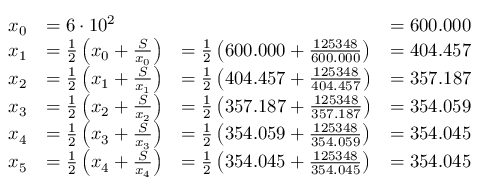Convert formula to latex. <formula><loc_0><loc_0><loc_500><loc_500>{ \begin{array} { r } { { \begin{array} { r l l l } { x _ { 0 } } & { = 6 \cdot 1 0 ^ { 2 } } & & { = 6 0 0 . 0 0 0 } \\ { x _ { 1 } } & { = { \frac { 1 } { 2 } } \left ( x _ { 0 } + { \frac { S } { x _ { 0 } } } \right ) } & { = { \frac { 1 } { 2 } } \left ( 6 0 0 . 0 0 0 + { \frac { 1 2 5 3 4 8 } { 6 0 0 . 0 0 0 } } \right ) } & { = 4 0 4 . 4 5 7 } \\ { x _ { 2 } } & { = { \frac { 1 } { 2 } } \left ( x _ { 1 } + { \frac { S } { x _ { 1 } } } \right ) } & { = { \frac { 1 } { 2 } } \left ( 4 0 4 . 4 5 7 + { \frac { 1 2 5 3 4 8 } { 4 0 4 . 4 5 7 } } \right ) } & { = 3 5 7 . 1 8 7 } \\ { x _ { 3 } } & { = { \frac { 1 } { 2 } } \left ( x _ { 2 } + { \frac { S } { x _ { 2 } } } \right ) } & { = { \frac { 1 } { 2 } } \left ( 3 5 7 . 1 8 7 + { \frac { 1 2 5 3 4 8 } { 3 5 7 . 1 8 7 } } \right ) } & { = 3 5 4 . 0 5 9 } \\ { x _ { 4 } } & { = { \frac { 1 } { 2 } } \left ( x _ { 3 } + { \frac { S } { x _ { 3 } } } \right ) } & { = { \frac { 1 } { 2 } } \left ( 3 5 4 . 0 5 9 + { \frac { 1 2 5 3 4 8 } { 3 5 4 . 0 5 9 } } \right ) } & { = 3 5 4 . 0 4 5 } \\ { x _ { 5 } } & { = { \frac { 1 } { 2 } } \left ( x _ { 4 } + { \frac { S } { x _ { 4 } } } \right ) } & { = { \frac { 1 } { 2 } } \left ( 3 5 4 . 0 4 5 + { \frac { 1 2 5 3 4 8 } { 3 5 4 . 0 4 5 } } \right ) } & { = 3 5 4 . 0 4 5 } \end{array} } } \end{array} }</formula> 